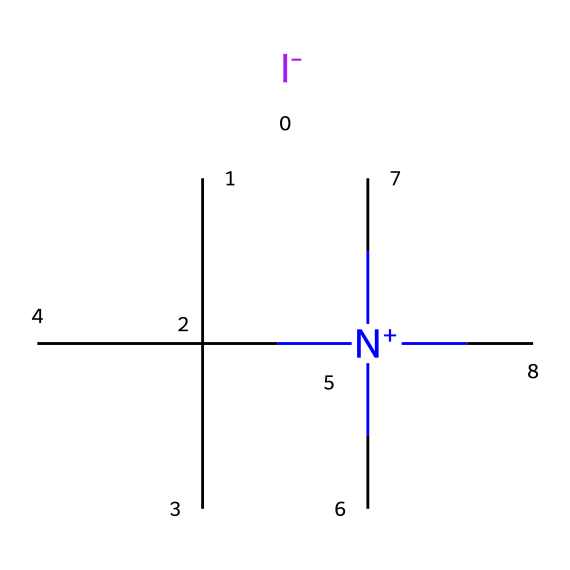What is the central atom in this compound? The central atom in this compound is nitrogen, as it is the atom that typically bonds to four substituents in this structure, surrounded by carbon and iodine.
Answer: nitrogen How many carbon atoms are present in the structure? By examining the SMILES representation, there are three carbon atoms indicated by CC(C)(C), which signifies that there are three carbon branches around the central nitrogen complex.
Answer: three What type of charge does the nitrogen have? The notation [N+](C)(C)C indicates that nitrogen carries a positive charge, as the plus sign represents a cationic state of the atom.
Answer: positive How many total atoms are in this chemical? To find the total number of atoms, count the individual C (3), H (9), I (1), and N (1) atoms from the structure to get a total of 14 atoms.
Answer: fourteen Is this compound hypervalent? Yes, the presence of nitrogen with a positive charge and more than four surrounding atoms suggests the compound exhibits hypervalent characteristics, typically indicating a central atom is bonded to more than four other atoms.
Answer: yes What functional group is indicative of the quaternary ammonium structure in this compound? The quaternary ammonium structure is represented by the nitrogen atom bonded to four carbon groups, which is a characteristic feature of this functional group.
Answer: quaternary ammonium What is the role of iodine in this sanitizing agent compound? Iodine primarily serves as an antimicrobial agent responsible for the sanitizing properties, effectively killing bacteria and other pathogens.
Answer: antimicrobial agent 